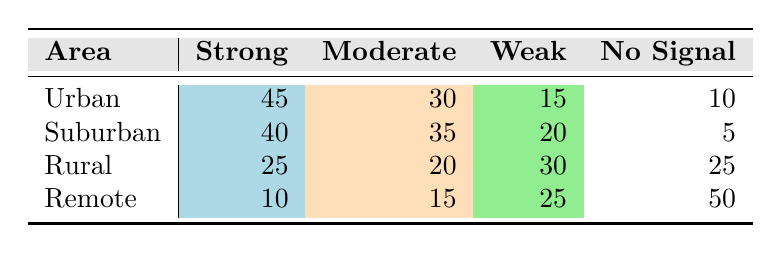What is the number of areas with 'No Signal' categorized as 'Strong'? In the table, the 'Strong' category shows counts for each area: Urban (45), Suburban (40), Rural (25), and Remote (10). The 'No Signal' category does not contain any corresponding values for 'Strong'. Thus, the total count of 'No Signal' for 'Strong' is 0.
Answer: 0 Which area has the highest count of 'Weak' signals? The 'Weak' signal counts by area are: Urban (15), Suburban (20), Rural (30), and Remote (25). Among these, Rural has the highest count of 'Weak' signals at 30.
Answer: Rural What is the ratio of 'Strong' signals in the Urban area to 'No Signal' signals in the Remote area? The number of 'Strong' signals in Urban is 45, while the number of 'No Signal' signals in Remote is 50. The ratio is calculated as 45:50, which simplifies to 9:10.
Answer: 9:10 Is it true that the Suburban area has more 'Moderate' signals than the Urban area has of 'Weak' signals? The 'Moderate' signals in Suburban are 35 and 'Weak' signals in Urban are 15. Comparing these two, 35 is greater than 15, confirming the statement is true.
Answer: Yes What is the total count of 'Moderate' signals across all areas? The counts of 'Moderate' signals are: Urban (30), Suburban (35), Rural (20), and Remote (15). Summing these gives 30 + 35 + 20 + 15 = 100.
Answer: 100 Which area has the least number of 'Strong' signals? The counts of 'Strong' signals are: Urban (45), Suburban (40), Rural (25), and Remote (10). The least number of 'Strong' signals is found in Remote with 10.
Answer: Remote How many more 'No Signal' counts are there in the Remote area compared to the Urban area? The 'No Signal' counts are Urban (10) and Remote (50). To find how many more there are in Remote, we subtract: 50 - 10 = 40.
Answer: 40 What is the average number of 'Strong' signals across all areas? The totals of 'Strong' signals are: 45 (Urban) + 40 (Suburban) + 25 (Rural) + 10 (Remote) = 120. There are 4 areas, so the average is 120 / 4 = 30.
Answer: 30 Is the number of 'Weak' signals greater than the number of 'Strong' signals in the Rural area? In Rural, there are 30 'Weak' signals and 25 'Strong' signals. Since 30 is greater than 25, the statement is true.
Answer: Yes 